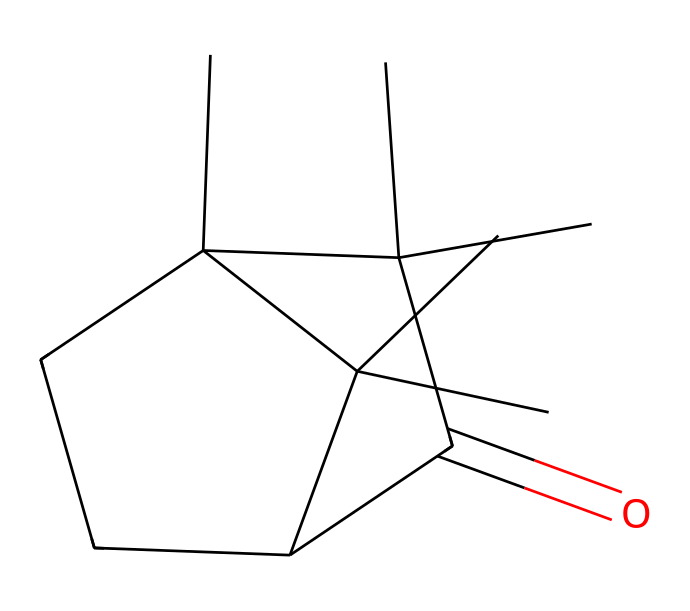What is the name of the chemical represented by this SMILES? The SMILES notation indicates the presence of a ketone functional group (C(=O)) along with a complex cyclic structure. This corresponds to camphor, a well-known ketone found in essential oils.
Answer: camphor How many carbon atoms are in the structure? To determine the number of carbon atoms, we can analyze the SMILES notation, counting each 'C' for carbon. The structure contains a total of 10 carbon atoms.
Answer: 10 What type of functional group is present in this molecule? The presence of C(=O) in the structure indicates a ketone group, which is a characteristic functional group in ketones.
Answer: ketone What is the total number of rings in the molecular structure? By examining the SMILES, we see the presence of two 'C1' and 'C2' designators indicating that there are two rings in the structure.
Answer: 2 What effect does the presence of the ketone group have on the reactivity of camphor? The ketone functional group affects the reactivity of camphor by making it more susceptible to nucleophilic attack due to the partial positive charge on the carbonyl carbon. This is a common behavior of ketones.
Answer: increased reactivity What is the molecular formula for camphor? By calculating the total number of each type of atom from the structure (10 carbon, 16 hydrogen, and 1 oxygen), we can derive the molecular formula for camphor, which is C10H16O.
Answer: C10H16O 